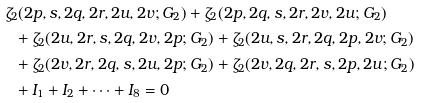<formula> <loc_0><loc_0><loc_500><loc_500>& \zeta _ { 2 } ( 2 p , s , 2 q , 2 r , 2 u , 2 v ; G _ { 2 } ) + \zeta _ { 2 } ( 2 p , 2 q , s , 2 r , 2 v , 2 u ; G _ { 2 } ) \\ & \ \ + \zeta _ { 2 } ( 2 u , 2 r , s , 2 q , 2 v , 2 p ; G _ { 2 } ) + \zeta _ { 2 } ( 2 u , s , 2 r , 2 q , 2 p , 2 v ; G _ { 2 } ) \\ & \ \ + \zeta _ { 2 } ( 2 v , 2 r , 2 q , s , 2 u , 2 p ; G _ { 2 } ) + \zeta _ { 2 } ( 2 v , 2 q , 2 r , s , 2 p , 2 u ; G _ { 2 } ) \\ & \ \ + I _ { 1 } + I _ { 2 } + \cdots + I _ { 8 } = 0</formula> 